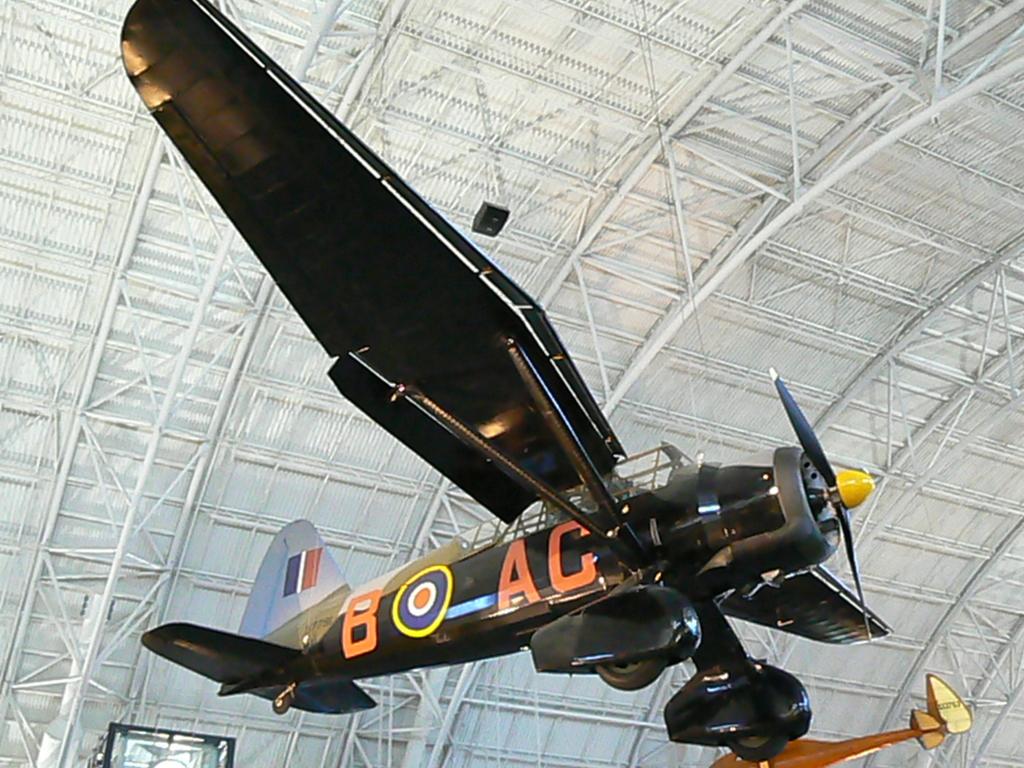What is written on the side of the plane?
Offer a terse response. B ac. 